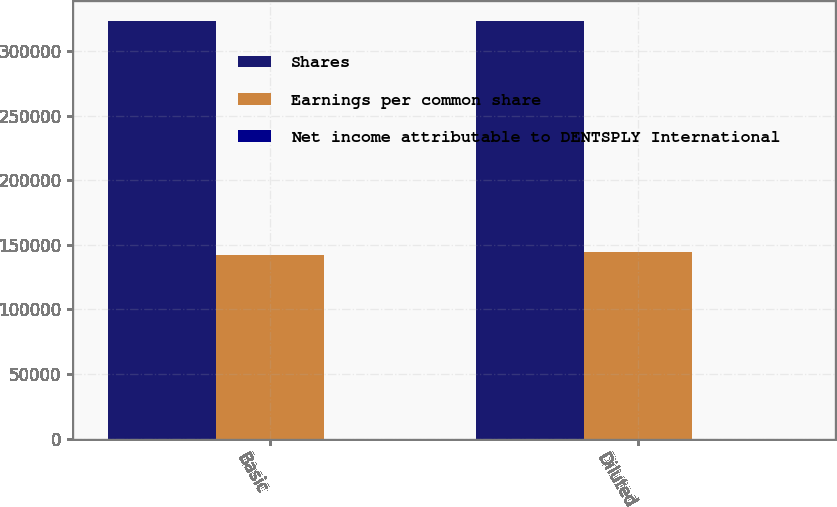Convert chart. <chart><loc_0><loc_0><loc_500><loc_500><stacked_bar_chart><ecel><fcel>Basic<fcel>Diluted<nl><fcel>Shares<fcel>322854<fcel>322854<nl><fcel>Earnings per common share<fcel>141714<fcel>144219<nl><fcel>Net income attributable to DENTSPLY International<fcel>2.28<fcel>2.24<nl></chart> 